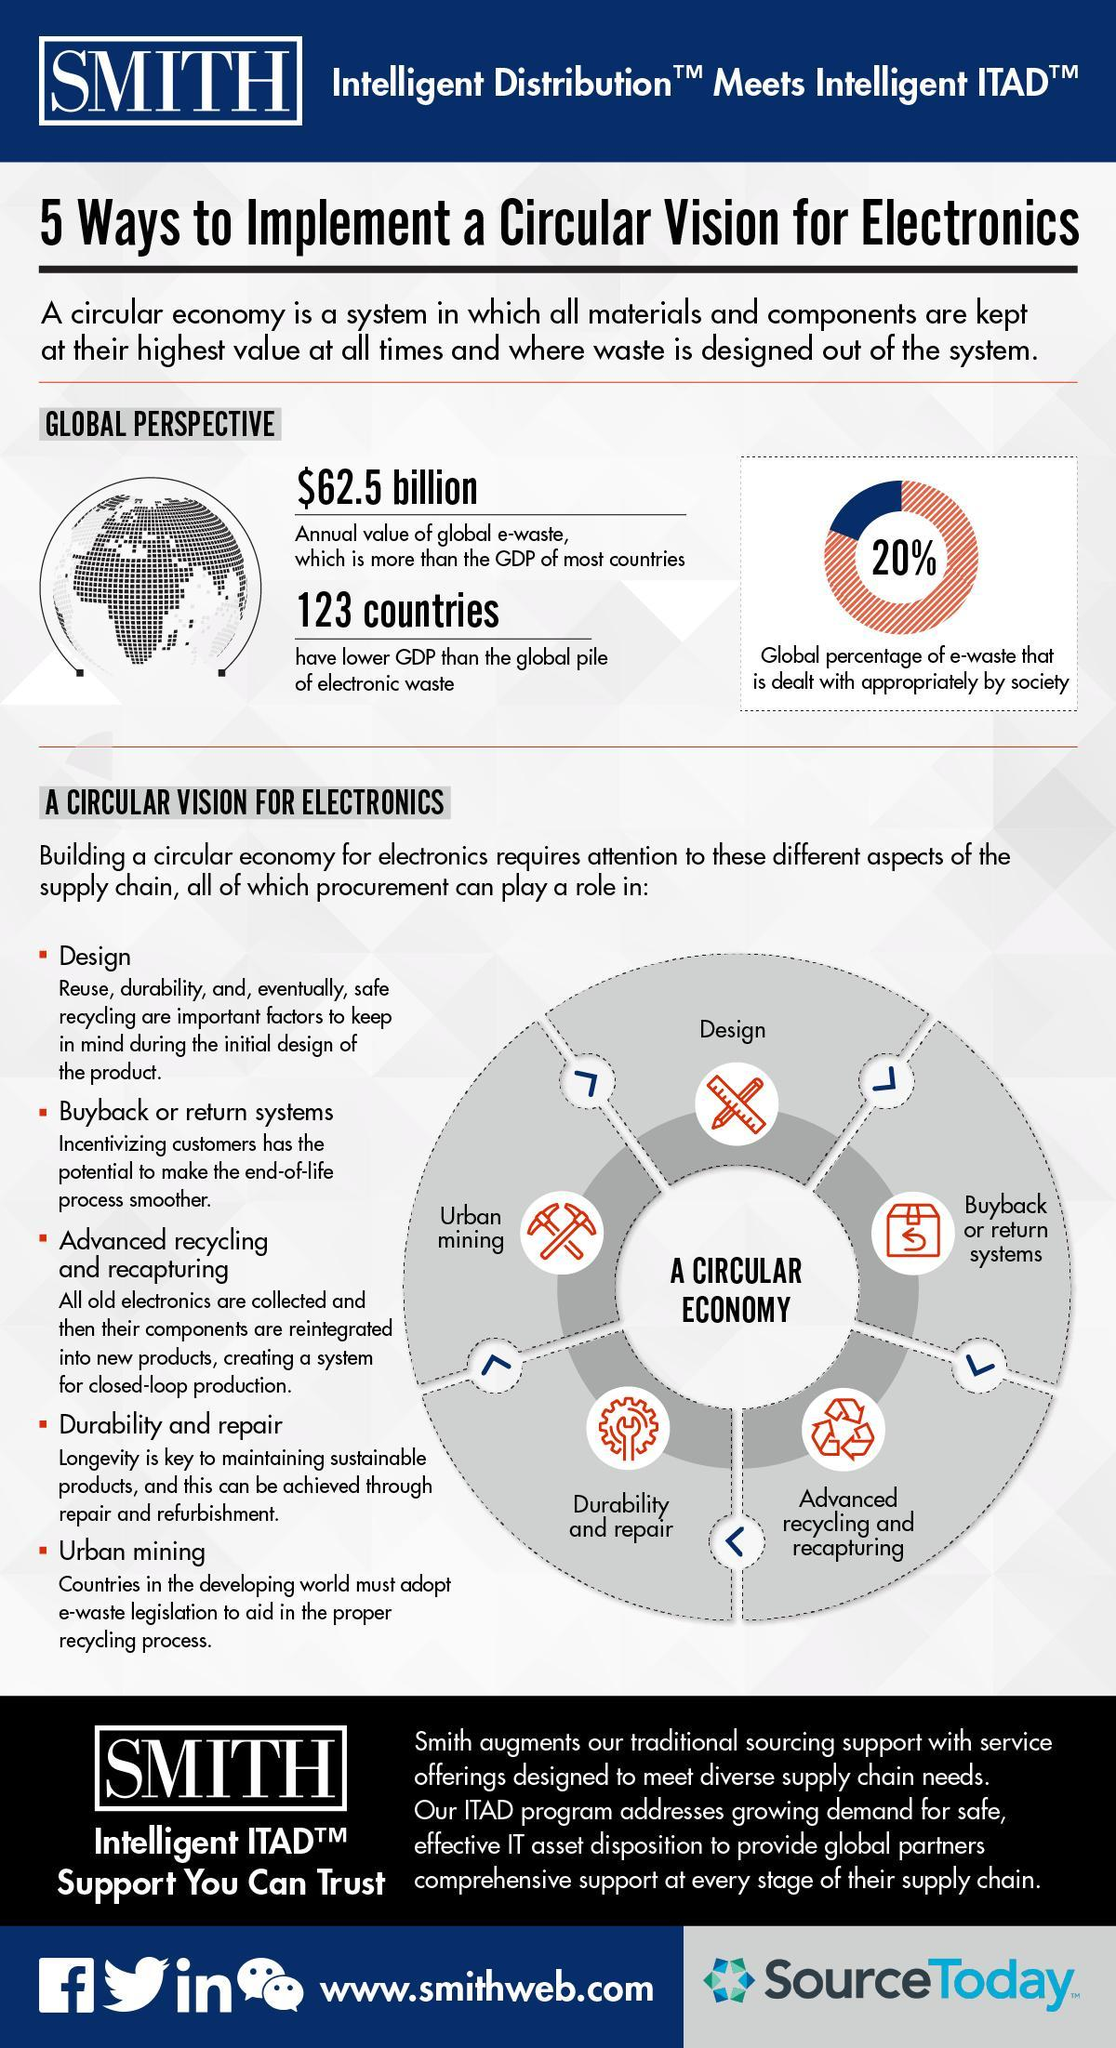What is the annual value of global e-waste?
Answer the question with a short phrase. $62.5 billion What percentage of global e-waste is not dealt appropriately by the society? 80% 